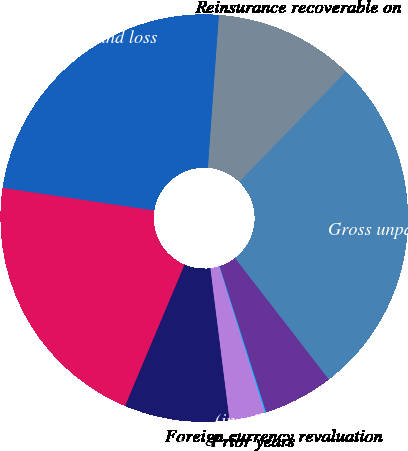<chart> <loc_0><loc_0><loc_500><loc_500><pie_chart><fcel>(in millions of US dollars)<fcel>Gross unpaid losses and loss<fcel>Reinsurance recoverable on<fcel>Net unpaid losses and loss<fcel>Total<fcel>Current year<fcel>Prior years<fcel>Foreign currency revaluation<nl><fcel>5.58%<fcel>27.3%<fcel>11.08%<fcel>23.78%<fcel>21.03%<fcel>8.33%<fcel>2.83%<fcel>0.08%<nl></chart> 